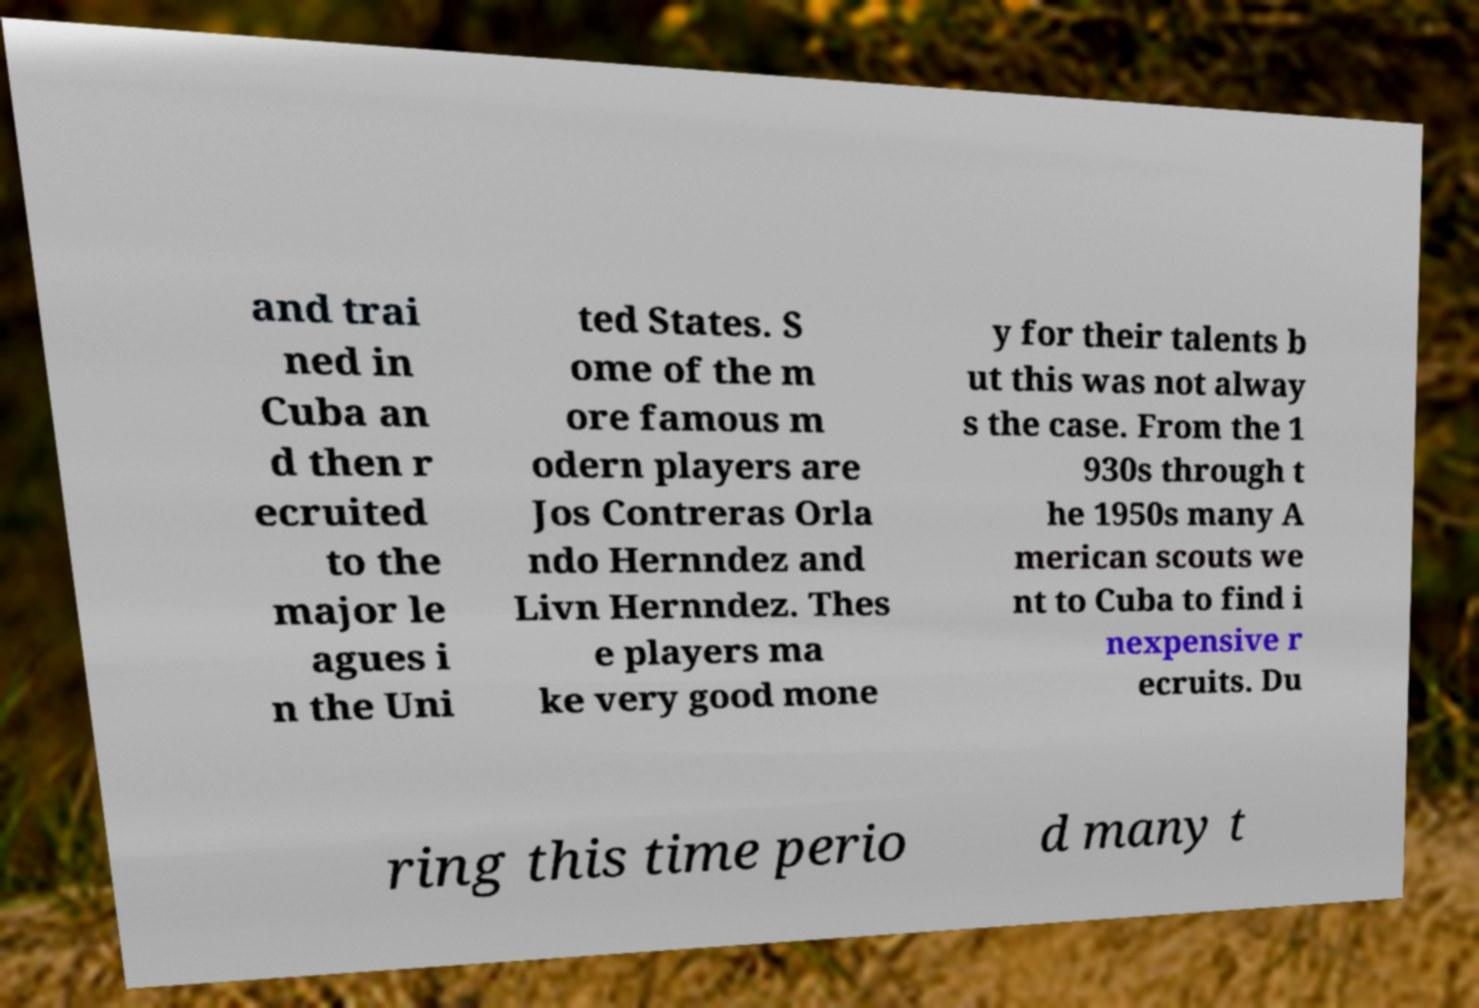Please read and relay the text visible in this image. What does it say? and trai ned in Cuba an d then r ecruited to the major le agues i n the Uni ted States. S ome of the m ore famous m odern players are Jos Contreras Orla ndo Hernndez and Livn Hernndez. Thes e players ma ke very good mone y for their talents b ut this was not alway s the case. From the 1 930s through t he 1950s many A merican scouts we nt to Cuba to find i nexpensive r ecruits. Du ring this time perio d many t 